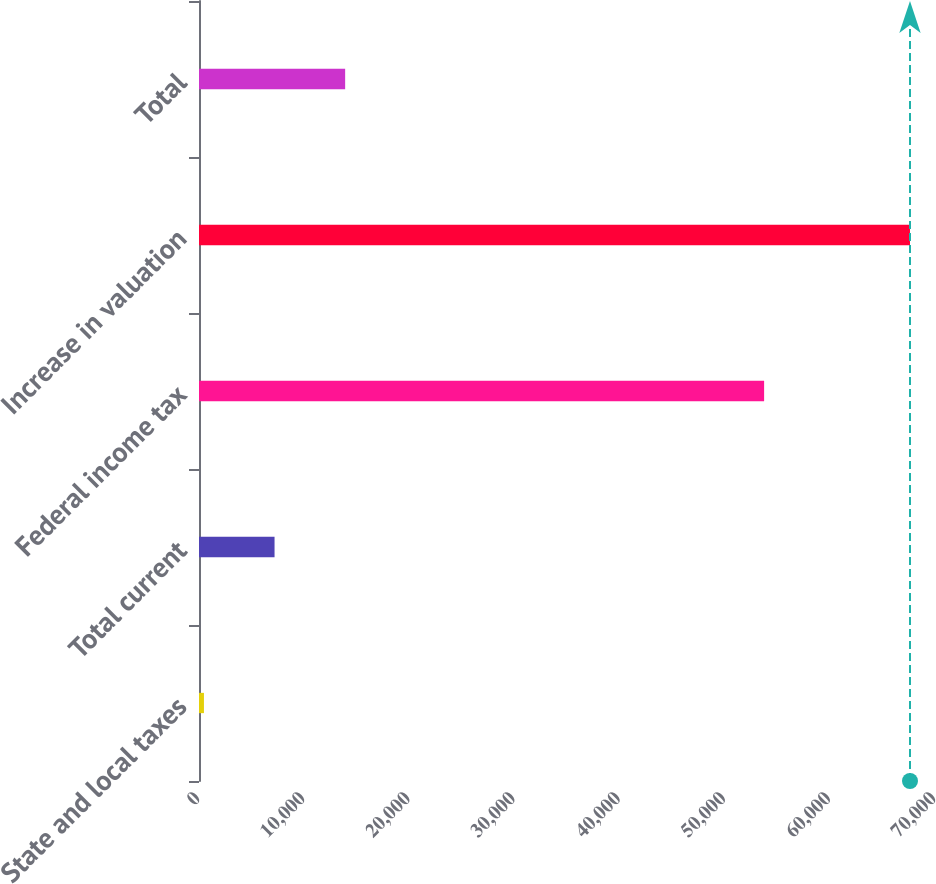Convert chart to OTSL. <chart><loc_0><loc_0><loc_500><loc_500><bar_chart><fcel>State and local taxes<fcel>Total current<fcel>Federal income tax<fcel>Increase in valuation<fcel>Total<nl><fcel>470<fcel>7185.1<fcel>53747<fcel>67621<fcel>13900.2<nl></chart> 